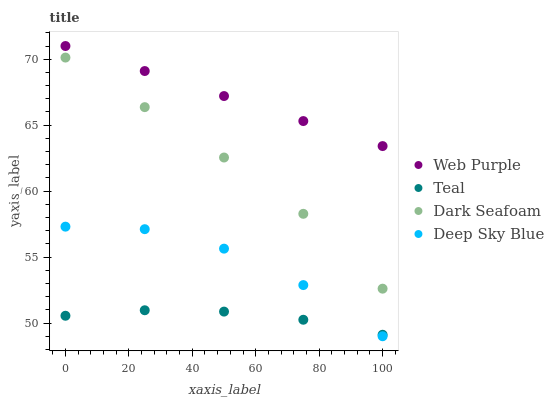Does Teal have the minimum area under the curve?
Answer yes or no. Yes. Does Web Purple have the maximum area under the curve?
Answer yes or no. Yes. Does Dark Seafoam have the minimum area under the curve?
Answer yes or no. No. Does Dark Seafoam have the maximum area under the curve?
Answer yes or no. No. Is Web Purple the smoothest?
Answer yes or no. Yes. Is Deep Sky Blue the roughest?
Answer yes or no. Yes. Is Dark Seafoam the smoothest?
Answer yes or no. No. Is Dark Seafoam the roughest?
Answer yes or no. No. Does Deep Sky Blue have the lowest value?
Answer yes or no. Yes. Does Dark Seafoam have the lowest value?
Answer yes or no. No. Does Web Purple have the highest value?
Answer yes or no. Yes. Does Dark Seafoam have the highest value?
Answer yes or no. No. Is Dark Seafoam less than Web Purple?
Answer yes or no. Yes. Is Web Purple greater than Teal?
Answer yes or no. Yes. Does Teal intersect Deep Sky Blue?
Answer yes or no. Yes. Is Teal less than Deep Sky Blue?
Answer yes or no. No. Is Teal greater than Deep Sky Blue?
Answer yes or no. No. Does Dark Seafoam intersect Web Purple?
Answer yes or no. No. 